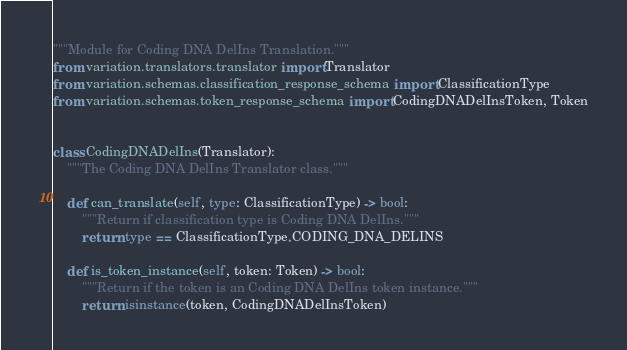<code> <loc_0><loc_0><loc_500><loc_500><_Python_>"""Module for Coding DNA DelIns Translation."""
from variation.translators.translator import Translator
from variation.schemas.classification_response_schema import ClassificationType
from variation.schemas.token_response_schema import CodingDNADelInsToken, Token


class CodingDNADelIns(Translator):
    """The Coding DNA DelIns Translator class."""

    def can_translate(self, type: ClassificationType) -> bool:
        """Return if classification type is Coding DNA DelIns."""
        return type == ClassificationType.CODING_DNA_DELINS

    def is_token_instance(self, token: Token) -> bool:
        """Return if the token is an Coding DNA DelIns token instance."""
        return isinstance(token, CodingDNADelInsToken)
</code> 